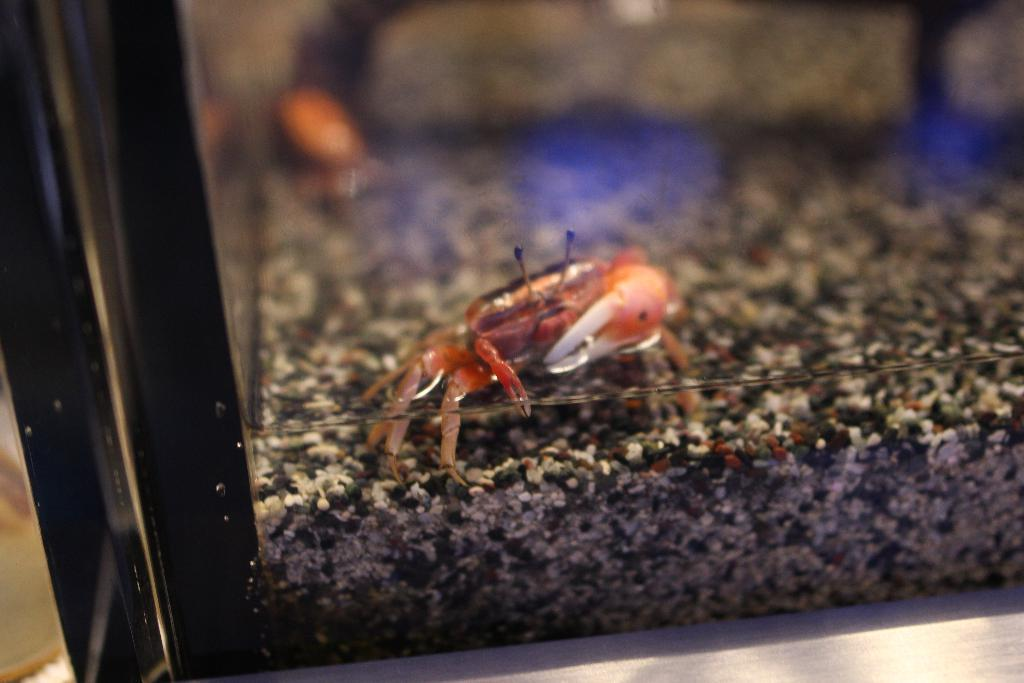What is the main subject of the image? The main subject of the image is a crab. Where is the crab located? The crab is on the sand surface. Is there anything covering the crab? Yes, the crab is covered with a glass. Can you describe the background of the image? The background is blurred. How many houses can be seen in the image? There are no houses present in the image; it features a crab on the sand surface. What type of apples are being used as a decoration in the image? There are no apples present in the image; it features a crab on the sand surface. 